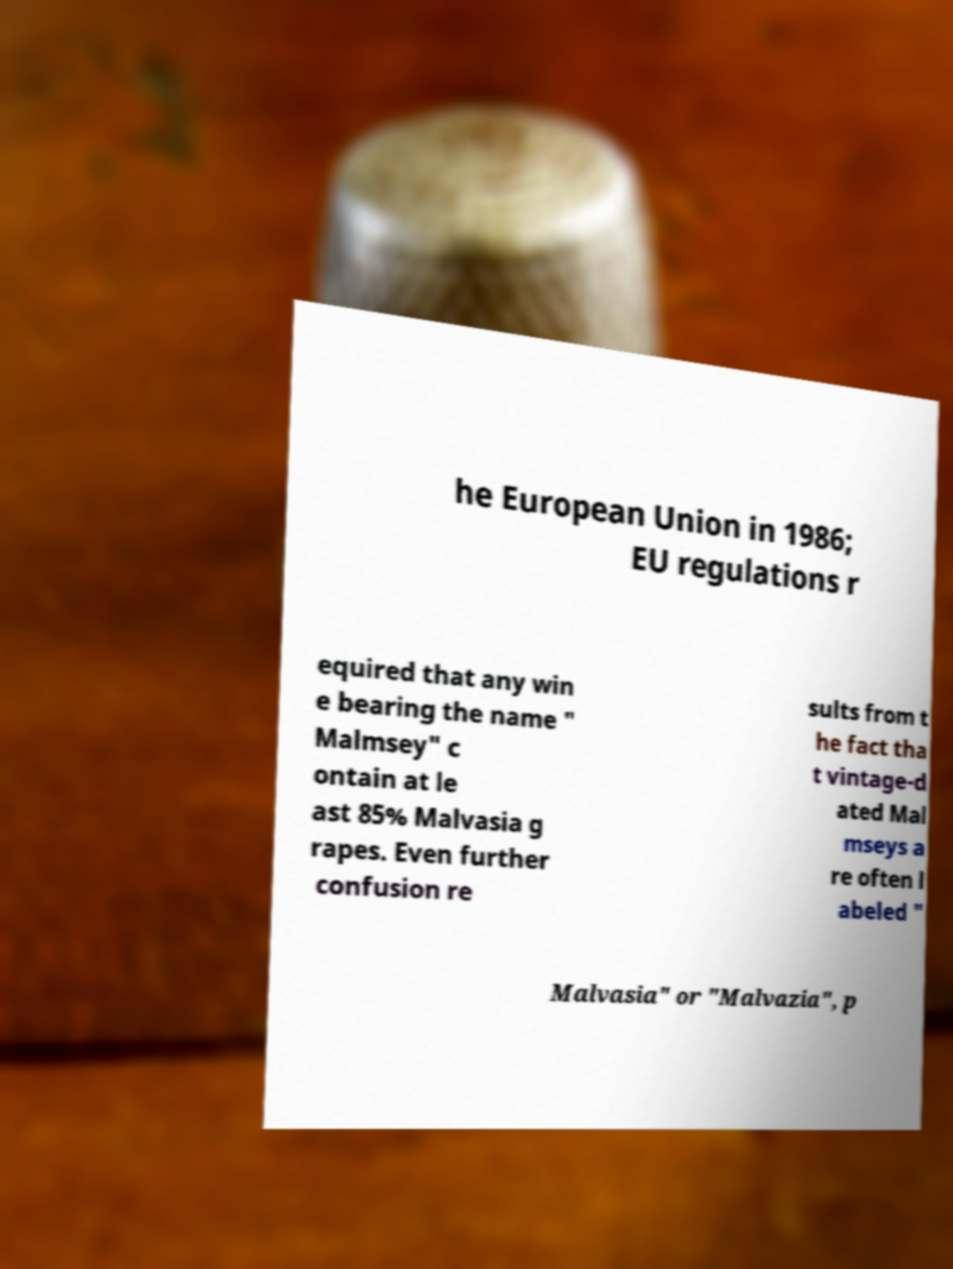Can you accurately transcribe the text from the provided image for me? he European Union in 1986; EU regulations r equired that any win e bearing the name " Malmsey" c ontain at le ast 85% Malvasia g rapes. Even further confusion re sults from t he fact tha t vintage-d ated Mal mseys a re often l abeled " Malvasia" or "Malvazia", p 